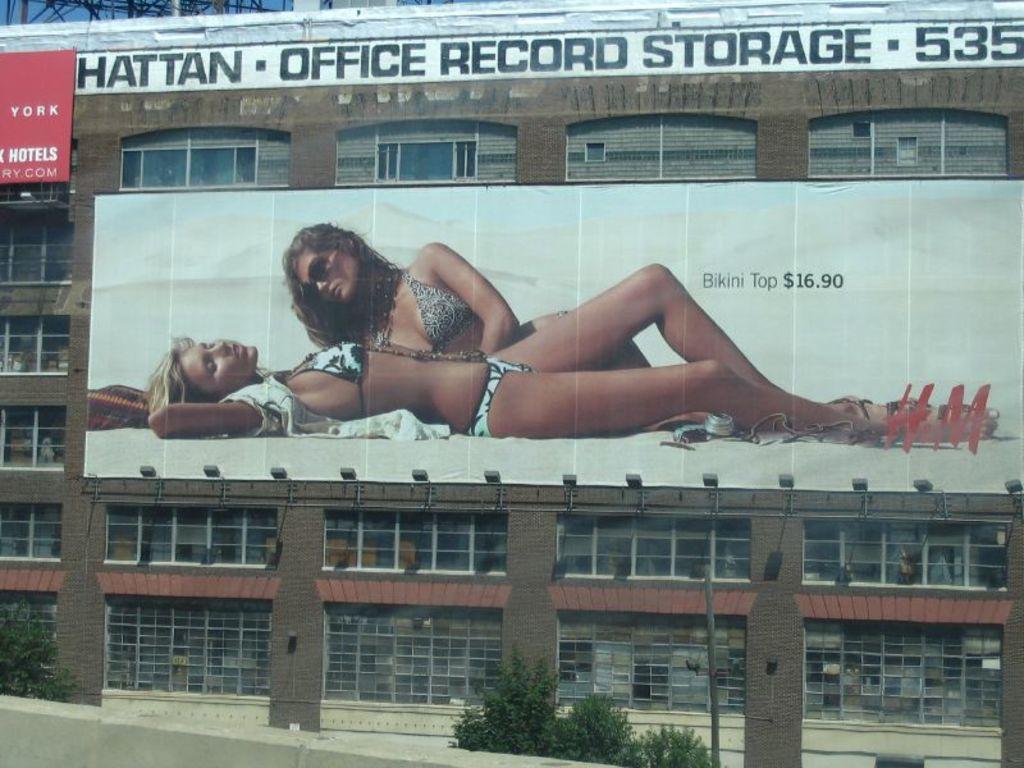What office building is that?
Provide a succinct answer. Hattan office record storage. How much is the bikini top?
Make the answer very short. 16.90. 